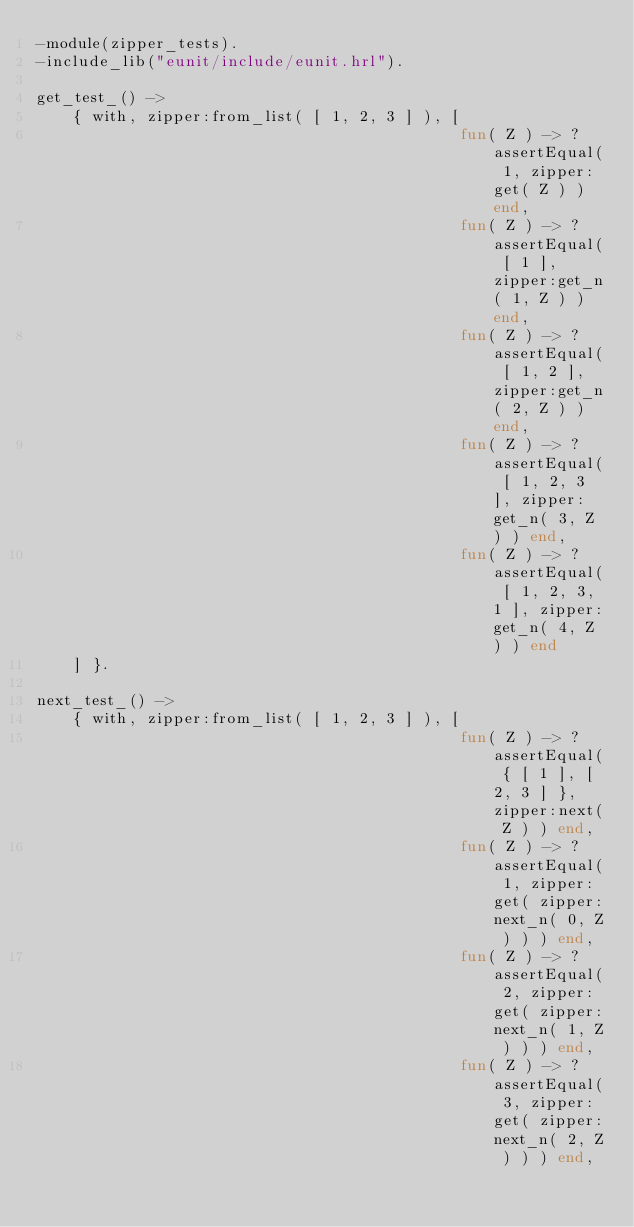<code> <loc_0><loc_0><loc_500><loc_500><_Erlang_>-module(zipper_tests).
-include_lib("eunit/include/eunit.hrl").

get_test_() ->
    { with, zipper:from_list( [ 1, 2, 3 ] ), [
                                              fun( Z ) -> ?assertEqual( 1, zipper:get( Z ) ) end,
                                              fun( Z ) -> ?assertEqual( [ 1 ], zipper:get_n( 1, Z ) ) end,
                                              fun( Z ) -> ?assertEqual( [ 1, 2 ], zipper:get_n( 2, Z ) ) end,
                                              fun( Z ) -> ?assertEqual( [ 1, 2, 3 ], zipper:get_n( 3, Z ) ) end,
                                              fun( Z ) -> ?assertEqual( [ 1, 2, 3, 1 ], zipper:get_n( 4, Z ) ) end
    ] }.

next_test_() ->
    { with, zipper:from_list( [ 1, 2, 3 ] ), [
                                              fun( Z ) -> ?assertEqual( { [ 1 ], [ 2, 3 ] }, zipper:next( Z ) ) end,
                                              fun( Z ) -> ?assertEqual( 1, zipper:get( zipper:next_n( 0, Z ) ) ) end,
                                              fun( Z ) -> ?assertEqual( 2, zipper:get( zipper:next_n( 1, Z ) ) ) end,
                                              fun( Z ) -> ?assertEqual( 3, zipper:get( zipper:next_n( 2, Z ) ) ) end,</code> 